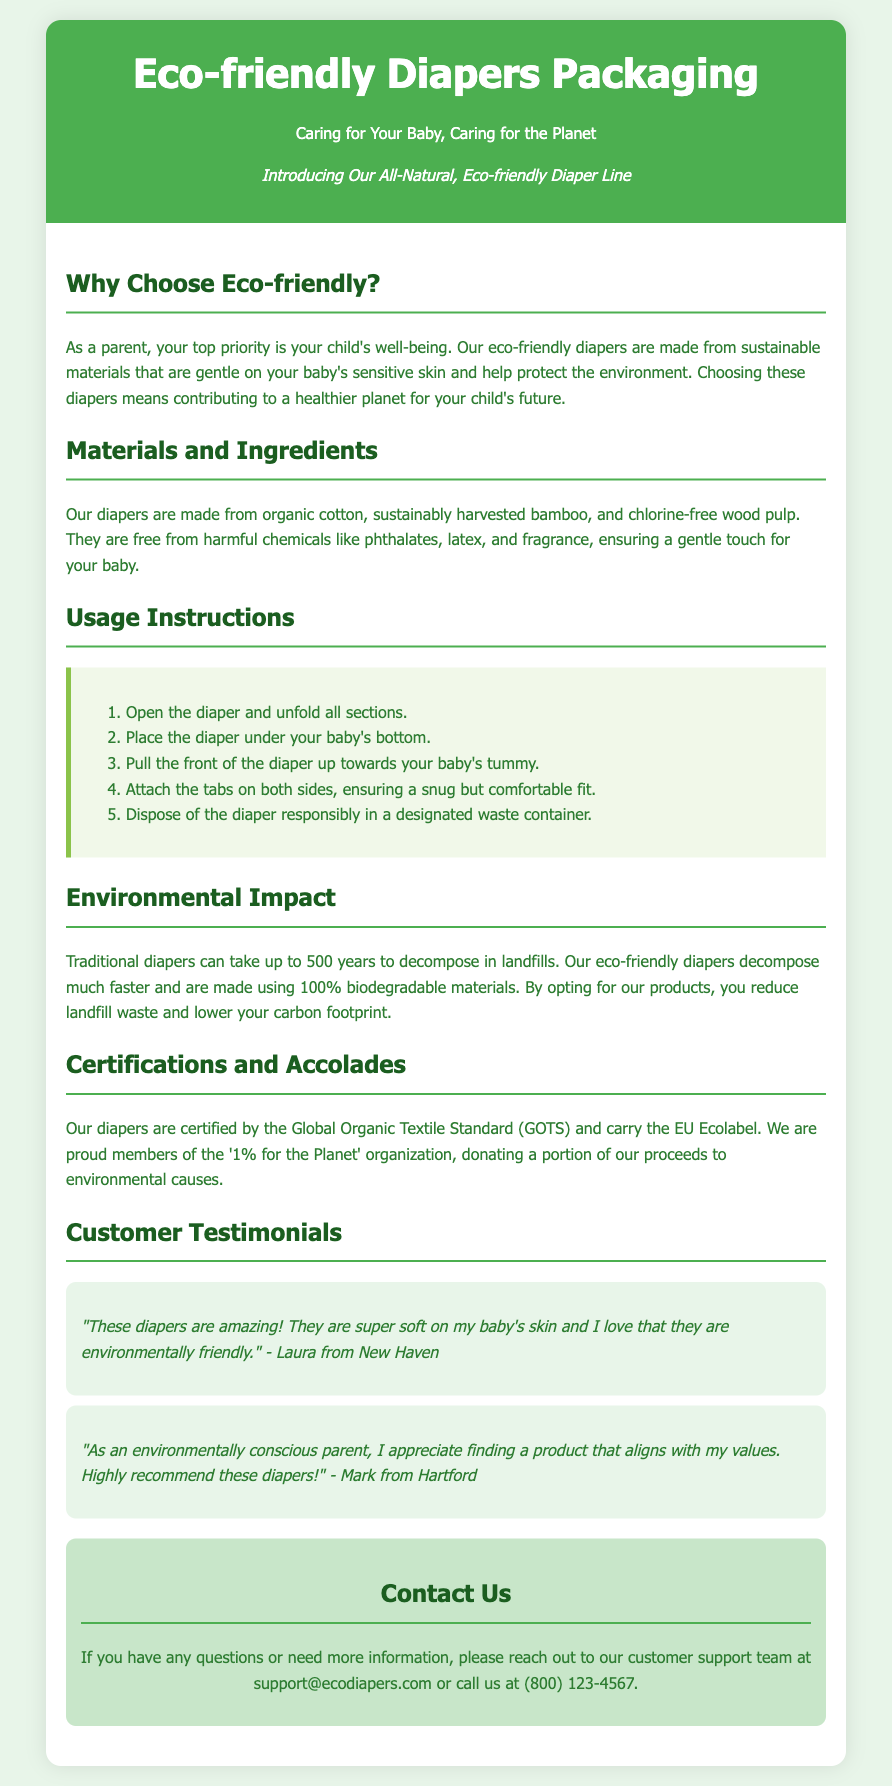What materials are used in the diapers? The document lists the materials as organic cotton, sustainably harvested bamboo, and chlorine-free wood pulp.
Answer: organic cotton, sustainably harvested bamboo, and chlorine-free wood pulp How long do traditional diapers take to decompose? The document states that traditional diapers can take up to 500 years to decompose in landfills.
Answer: 500 years What certification do the diapers have? The document mentions that the diapers are certified by the Global Organic Textile Standard (GOTS).
Answer: Global Organic Textile Standard (GOTS) What is one ingredient that the diapers are free from? The document lists harmful chemicals that the diapers are free from, including phthalates, latex, and fragrance.
Answer: phthalates What is the purpose of choosing eco-friendly diapers according to the document? The document suggests that choosing eco-friendly diapers helps protect the environment and contributes to a healthier planet for the child's future.
Answer: contribute to a healthier planet What is the final step in the usage instructions? The document outlines that the final step is to dispose of the diaper responsibly in a designated waste container.
Answer: dispose of the diaper responsibly How does the company contribute to environmental causes? The document states that the company is a proud member of the '1% for the Planet' organization, donating a portion of its proceeds to environmental causes.
Answer: donating a portion of our proceeds What can parents look forward to in customer testimonials? The document includes customer testimonials praising the diapers for being soft on baby's skin and environmentally friendly.
Answer: soft on my baby's skin and environmentally friendly 